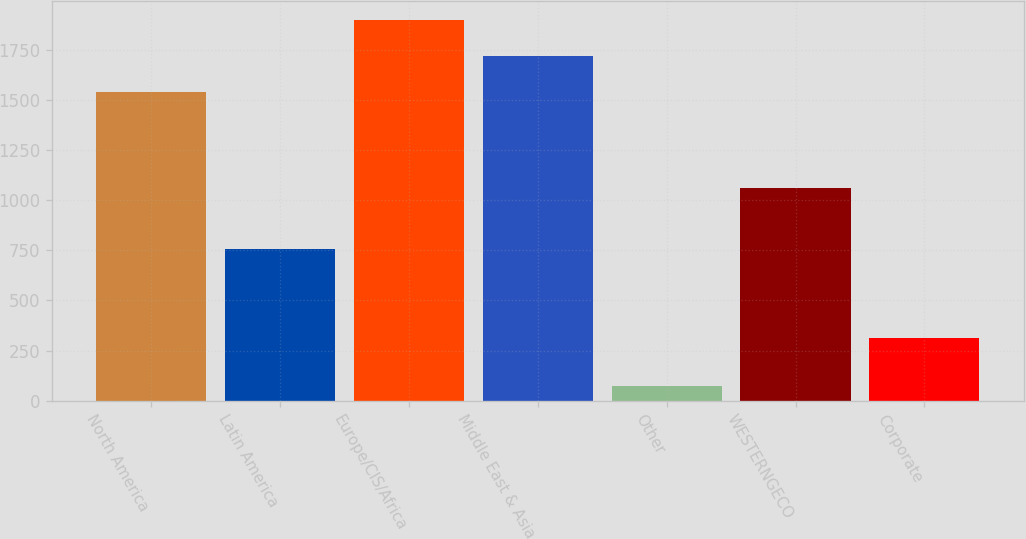Convert chart to OTSL. <chart><loc_0><loc_0><loc_500><loc_500><bar_chart><fcel>North America<fcel>Latin America<fcel>Europe/CIS/Africa<fcel>Middle East & Asia<fcel>Other<fcel>WESTERNGECO<fcel>Corporate<nl><fcel>1537<fcel>755<fcel>1899<fcel>1718<fcel>75<fcel>1060<fcel>311<nl></chart> 